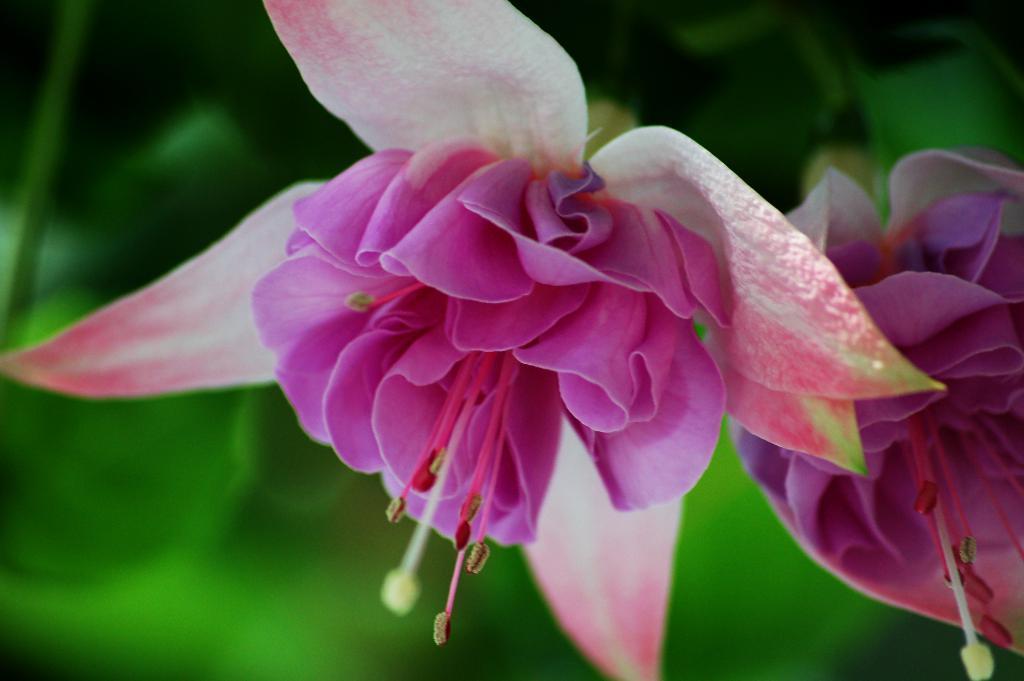Can you describe this image briefly? In this image, we can see some flowers and the background is blurred. 